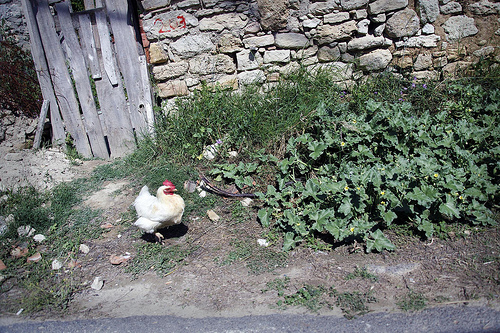<image>
Is the pigeon on the grass? No. The pigeon is not positioned on the grass. They may be near each other, but the pigeon is not supported by or resting on top of the grass. 